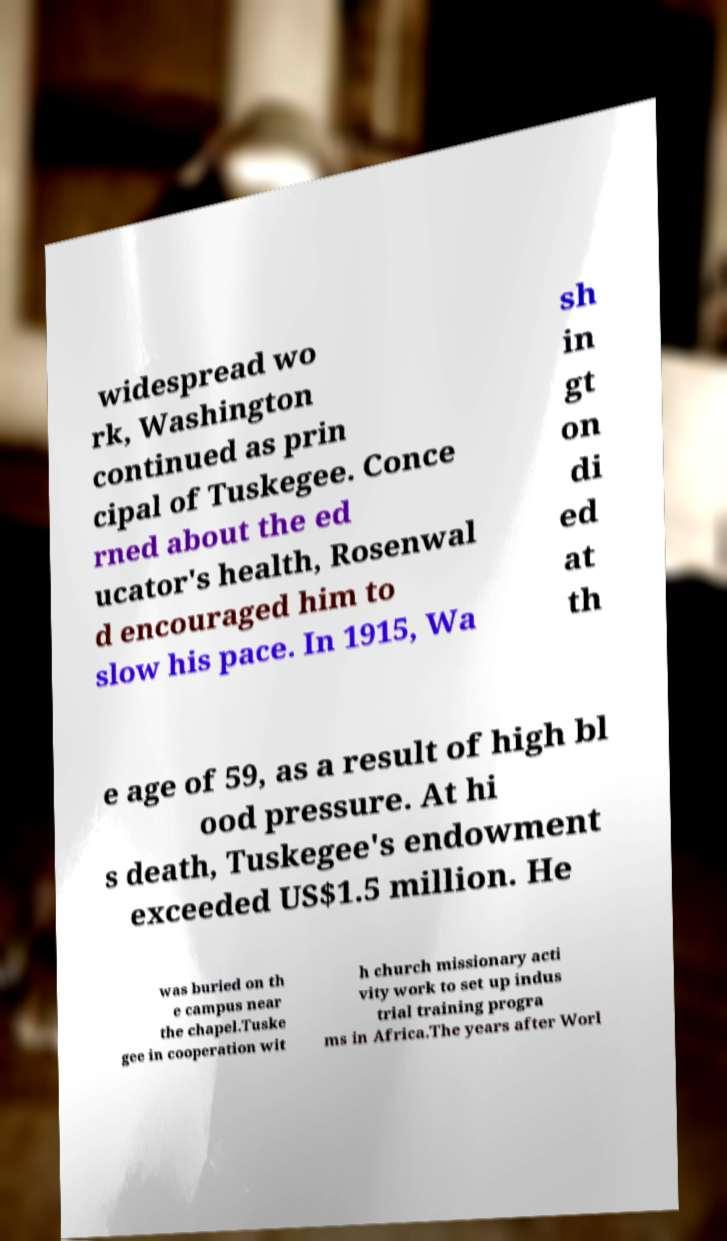Please read and relay the text visible in this image. What does it say? widespread wo rk, Washington continued as prin cipal of Tuskegee. Conce rned about the ed ucator's health, Rosenwal d encouraged him to slow his pace. In 1915, Wa sh in gt on di ed at th e age of 59, as a result of high bl ood pressure. At hi s death, Tuskegee's endowment exceeded US$1.5 million. He was buried on th e campus near the chapel.Tuske gee in cooperation wit h church missionary acti vity work to set up indus trial training progra ms in Africa.The years after Worl 